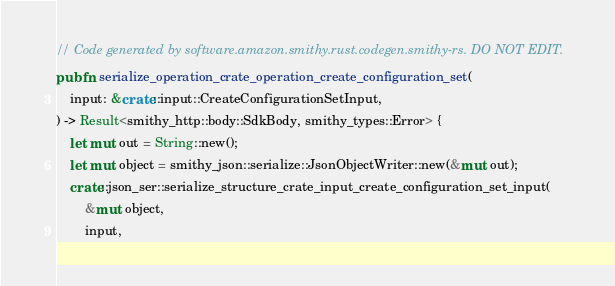Convert code to text. <code><loc_0><loc_0><loc_500><loc_500><_Rust_>// Code generated by software.amazon.smithy.rust.codegen.smithy-rs. DO NOT EDIT.
pub fn serialize_operation_crate_operation_create_configuration_set(
    input: &crate::input::CreateConfigurationSetInput,
) -> Result<smithy_http::body::SdkBody, smithy_types::Error> {
    let mut out = String::new();
    let mut object = smithy_json::serialize::JsonObjectWriter::new(&mut out);
    crate::json_ser::serialize_structure_crate_input_create_configuration_set_input(
        &mut object,
        input,</code> 